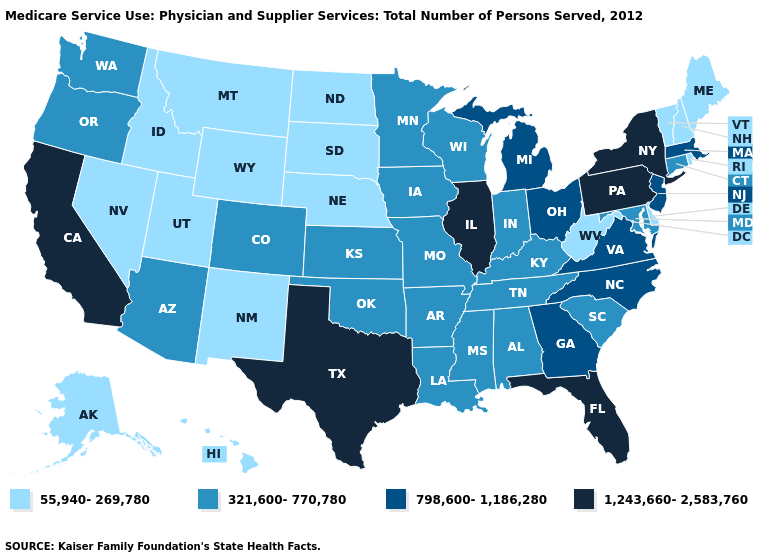What is the lowest value in the USA?
Give a very brief answer. 55,940-269,780. How many symbols are there in the legend?
Quick response, please. 4. What is the value of Delaware?
Concise answer only. 55,940-269,780. Does West Virginia have the lowest value in the South?
Answer briefly. Yes. What is the highest value in states that border Wyoming?
Be succinct. 321,600-770,780. Does the map have missing data?
Concise answer only. No. Among the states that border Massachusetts , which have the highest value?
Quick response, please. New York. What is the value of Alaska?
Give a very brief answer. 55,940-269,780. What is the lowest value in the Northeast?
Short answer required. 55,940-269,780. Which states have the lowest value in the South?
Quick response, please. Delaware, West Virginia. Does Virginia have the same value as Ohio?
Short answer required. Yes. Among the states that border West Virginia , which have the lowest value?
Be succinct. Kentucky, Maryland. Which states hav the highest value in the MidWest?
Keep it brief. Illinois. Does the first symbol in the legend represent the smallest category?
Keep it brief. Yes. What is the value of Texas?
Answer briefly. 1,243,660-2,583,760. 